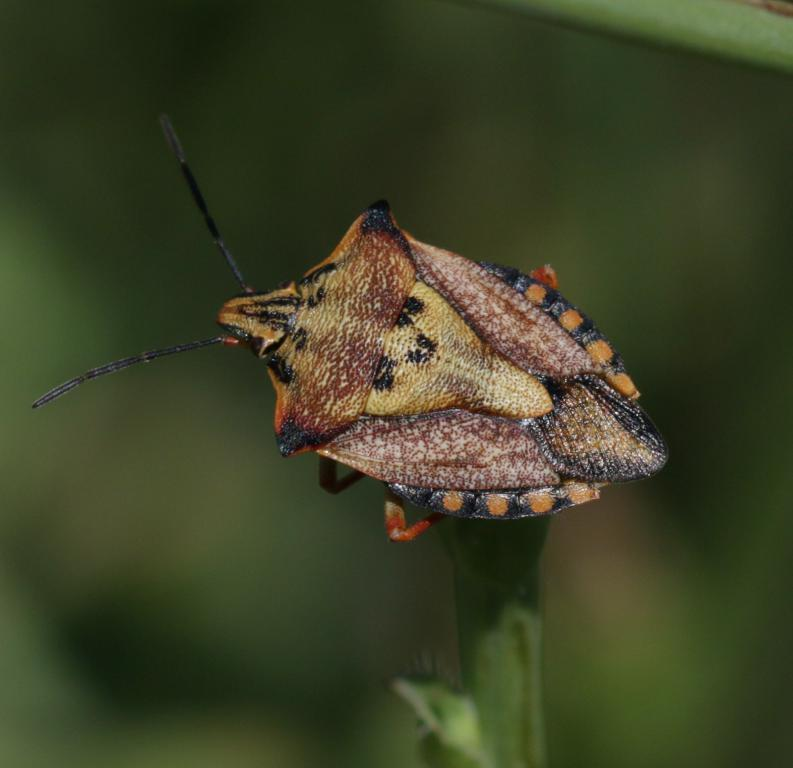What type of creature can be seen in the image? There is an insect in the image. Where is the insect located? The insect is on a stem. Can you describe the background of the image? The background of the image is blurry. How many women are sitting on the chairs in the image? There are no women or chairs present in the image; it features an insect on a stem with a blurry background. 